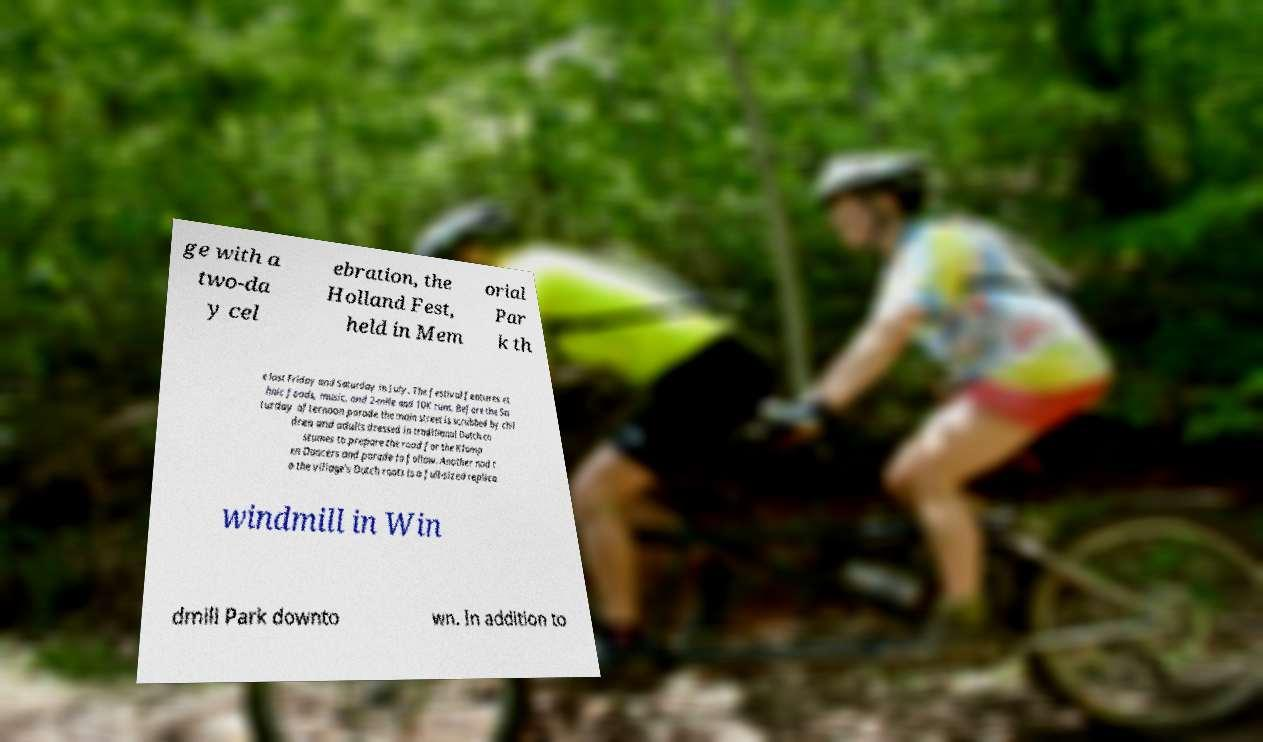There's text embedded in this image that I need extracted. Can you transcribe it verbatim? ge with a two-da y cel ebration, the Holland Fest, held in Mem orial Par k th e last Friday and Saturday in July. The festival features et hnic foods, music, and 2-mile and 10K runs. Before the Sa turday afternoon parade the main street is scrubbed by chil dren and adults dressed in traditional Dutch co stumes to prepare the road for the Klomp en Dancers and parade to follow. Another nod t o the village's Dutch roots is a full-sized replica windmill in Win dmill Park downto wn. In addition to 